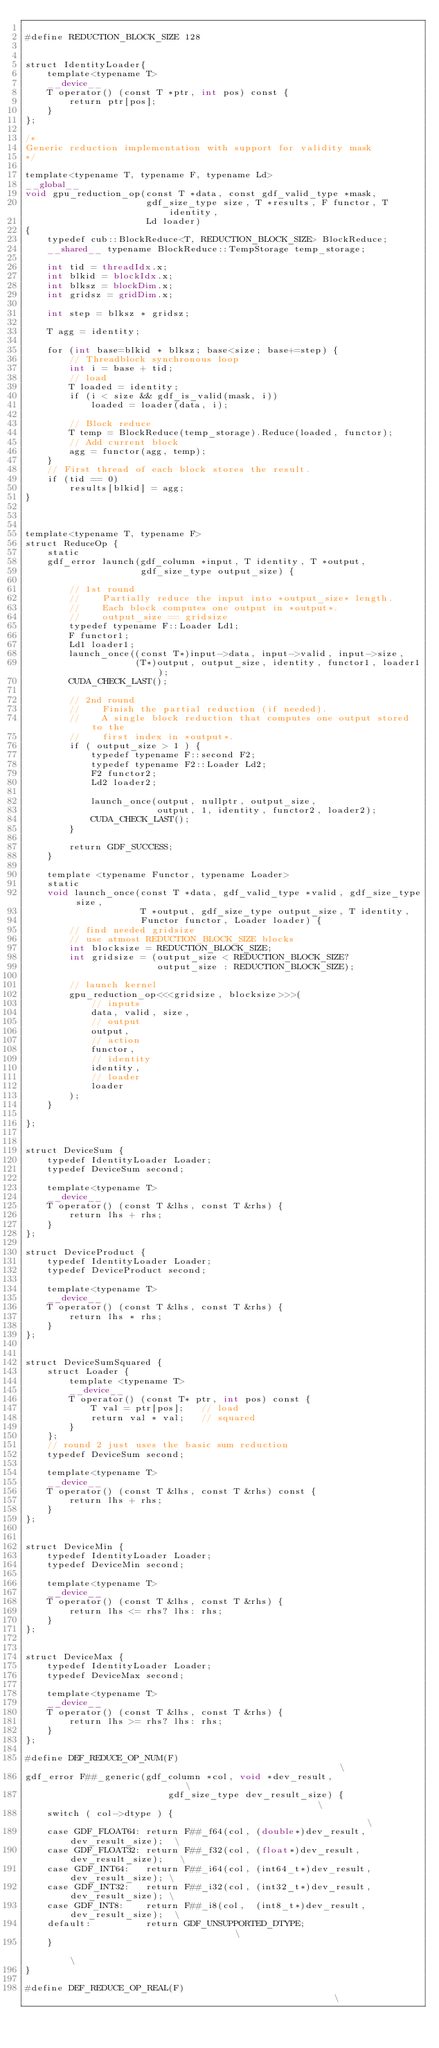<code> <loc_0><loc_0><loc_500><loc_500><_Cuda_>
#define REDUCTION_BLOCK_SIZE 128


struct IdentityLoader{
    template<typename T>
    __device__
    T operator() (const T *ptr, int pos) const {
        return ptr[pos];
    }
};

/*
Generic reduction implementation with support for validity mask
*/

template<typename T, typename F, typename Ld>
__global__
void gpu_reduction_op(const T *data, const gdf_valid_type *mask,
                      gdf_size_type size, T *results, F functor, T identity,
                      Ld loader)
{
    typedef cub::BlockReduce<T, REDUCTION_BLOCK_SIZE> BlockReduce;
    __shared__ typename BlockReduce::TempStorage temp_storage;

    int tid = threadIdx.x;
    int blkid = blockIdx.x;
    int blksz = blockDim.x;
    int gridsz = gridDim.x;

    int step = blksz * gridsz;

    T agg = identity;

    for (int base=blkid * blksz; base<size; base+=step) {
        // Threadblock synchronous loop
        int i = base + tid;
        // load
        T loaded = identity;
        if (i < size && gdf_is_valid(mask, i))
            loaded = loader(data, i);
            
        // Block reduce
        T temp = BlockReduce(temp_storage).Reduce(loaded, functor);
        // Add current block
        agg = functor(agg, temp);
    }
    // First thread of each block stores the result.
    if (tid == 0)
        results[blkid] = agg;
}



template<typename T, typename F>
struct ReduceOp {
    static
    gdf_error launch(gdf_column *input, T identity, T *output,
                     gdf_size_type output_size) {

        // 1st round
        //    Partially reduce the input into *output_size* length.
        //    Each block computes one output in *output*.
        //    output_size == gridsize
        typedef typename F::Loader Ld1;
        F functor1;
        Ld1 loader1;
        launch_once((const T*)input->data, input->valid, input->size,
                    (T*)output, output_size, identity, functor1, loader1);
        CUDA_CHECK_LAST();

        // 2nd round
        //    Finish the partial reduction (if needed).
        //    A single block reduction that computes one output stored to the
        //    first index in *output*.
        if ( output_size > 1 ) {
            typedef typename F::second F2;
            typedef typename F2::Loader Ld2;
            F2 functor2;
            Ld2 loader2;

            launch_once(output, nullptr, output_size,
                        output, 1, identity, functor2, loader2);
            CUDA_CHECK_LAST();
        }

        return GDF_SUCCESS;
    }

    template <typename Functor, typename Loader>
    static
    void launch_once(const T *data, gdf_valid_type *valid, gdf_size_type size,
                     T *output, gdf_size_type output_size, T identity,
                     Functor functor, Loader loader) {
        // find needed gridsize
        // use atmost REDUCTION_BLOCK_SIZE blocks
        int blocksize = REDUCTION_BLOCK_SIZE;
        int gridsize = (output_size < REDUCTION_BLOCK_SIZE?
                        output_size : REDUCTION_BLOCK_SIZE);

        // launch kernel
        gpu_reduction_op<<<gridsize, blocksize>>>(
            // inputs
            data, valid, size,
            // output
            output,
            // action
            functor,
            // identity
            identity,
            // loader
            loader
        );
    }

};


struct DeviceSum {
    typedef IdentityLoader Loader;
    typedef DeviceSum second;

    template<typename T>
    __device__
    T operator() (const T &lhs, const T &rhs) {
        return lhs + rhs;
    }
};

struct DeviceProduct {
    typedef IdentityLoader Loader;
    typedef DeviceProduct second;

    template<typename T>
    __device__
    T operator() (const T &lhs, const T &rhs) {
        return lhs * rhs;
    }
};


struct DeviceSumSquared {
    struct Loader {
        template <typename T>
        __device__
        T operator() (const T* ptr, int pos) const {
            T val = ptr[pos];   // load
            return val * val;   // squared
        }
    };
    // round 2 just uses the basic sum reduction
    typedef DeviceSum second;

    template<typename T>
    __device__
    T operator() (const T &lhs, const T &rhs) const {
        return lhs + rhs;
    }
};


struct DeviceMin {
    typedef IdentityLoader Loader;
    typedef DeviceMin second;

    template<typename T>
    __device__
    T operator() (const T &lhs, const T &rhs) {
        return lhs <= rhs? lhs: rhs;
    }
};


struct DeviceMax {
    typedef IdentityLoader Loader;
    typedef DeviceMax second;

    template<typename T>
    __device__
    T operator() (const T &lhs, const T &rhs) {
        return lhs >= rhs? lhs: rhs;
    }
};

#define DEF_REDUCE_OP_NUM(F)                                                      \
gdf_error F##_generic(gdf_column *col, void *dev_result,                          \
                          gdf_size_type dev_result_size) {                        \
    switch ( col->dtype ) {                                                       \
    case GDF_FLOAT64: return F##_f64(col, (double*)dev_result, dev_result_size);  \
    case GDF_FLOAT32: return F##_f32(col, (float*)dev_result, dev_result_size);   \
    case GDF_INT64:   return F##_i64(col, (int64_t*)dev_result, dev_result_size); \
    case GDF_INT32:   return F##_i32(col, (int32_t*)dev_result, dev_result_size); \
    case GDF_INT8:    return F##_i8(col,  (int8_t*)dev_result, dev_result_size);  \
    default:          return GDF_UNSUPPORTED_DTYPE;                               \
    }                                                                             \
}

#define DEF_REDUCE_OP_REAL(F)                                                     \</code> 